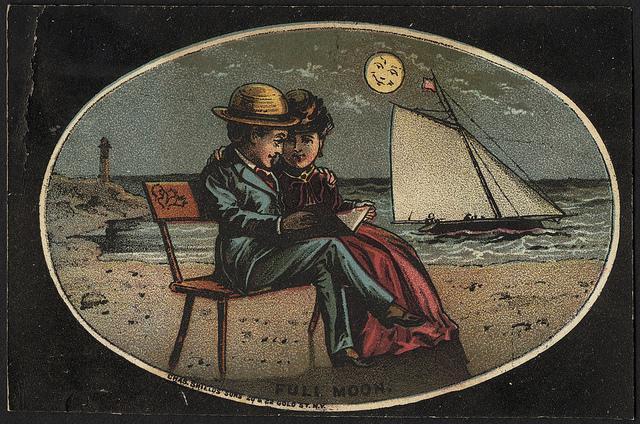How many people are sitting on the bench in this image?
Give a very brief answer. 2. 